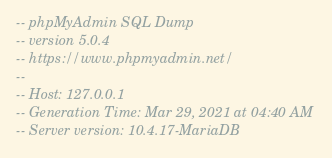Convert code to text. <code><loc_0><loc_0><loc_500><loc_500><_SQL_>-- phpMyAdmin SQL Dump
-- version 5.0.4
-- https://www.phpmyadmin.net/
--
-- Host: 127.0.0.1
-- Generation Time: Mar 29, 2021 at 04:40 AM
-- Server version: 10.4.17-MariaDB</code> 